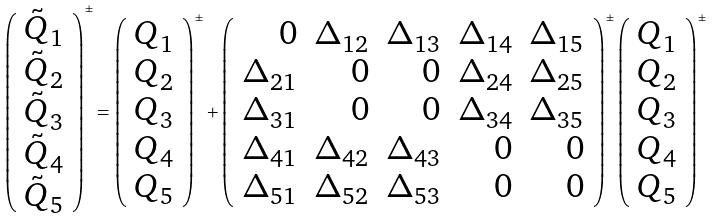Convert formula to latex. <formula><loc_0><loc_0><loc_500><loc_500>\left ( \begin{array} { c } \tilde { Q } _ { 1 } \\ \tilde { Q } _ { 2 } \\ \tilde { Q } _ { 3 } \\ \tilde { Q } _ { 4 } \\ \tilde { Q } _ { 5 } \end{array} \right ) ^ { \pm } = \left ( \begin{array} { c } Q _ { 1 } \\ Q _ { 2 } \\ Q _ { 3 } \\ Q _ { 4 } \\ Q _ { 5 } \end{array} \right ) ^ { \pm } + \left ( \begin{array} { r r r r r } 0 & \Delta _ { 1 2 } & \Delta _ { 1 3 } & \Delta _ { 1 4 } & \Delta _ { 1 5 } \\ \Delta _ { 2 1 } & 0 & 0 & \Delta _ { 2 4 } & \Delta _ { 2 5 } \\ \Delta _ { 3 1 } & 0 & 0 & \Delta _ { 3 4 } & \Delta _ { 3 5 } \\ \Delta _ { 4 1 } & \Delta _ { 4 2 } & \Delta _ { 4 3 } & 0 & 0 \\ \Delta _ { 5 1 } & \Delta _ { 5 2 } & \Delta _ { 5 3 } & 0 & 0 \end{array} \right ) ^ { \pm } \left ( \begin{array} { c } Q _ { 1 } \\ Q _ { 2 } \\ Q _ { 3 } \\ Q _ { 4 } \\ Q _ { 5 } \end{array} \right ) ^ { \pm }</formula> 